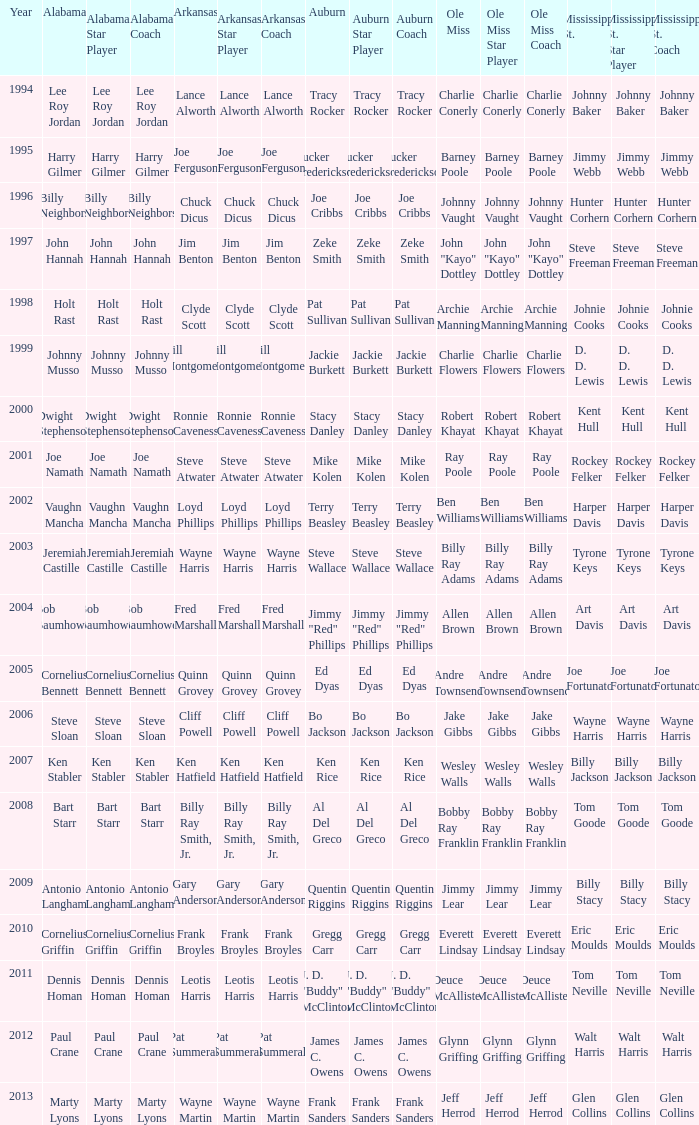Who was the Alabama player associated with Walt Harris? Paul Crane. 